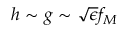<formula> <loc_0><loc_0><loc_500><loc_500>h \sim g \sim \sqrt { \epsilon } f _ { M }</formula> 